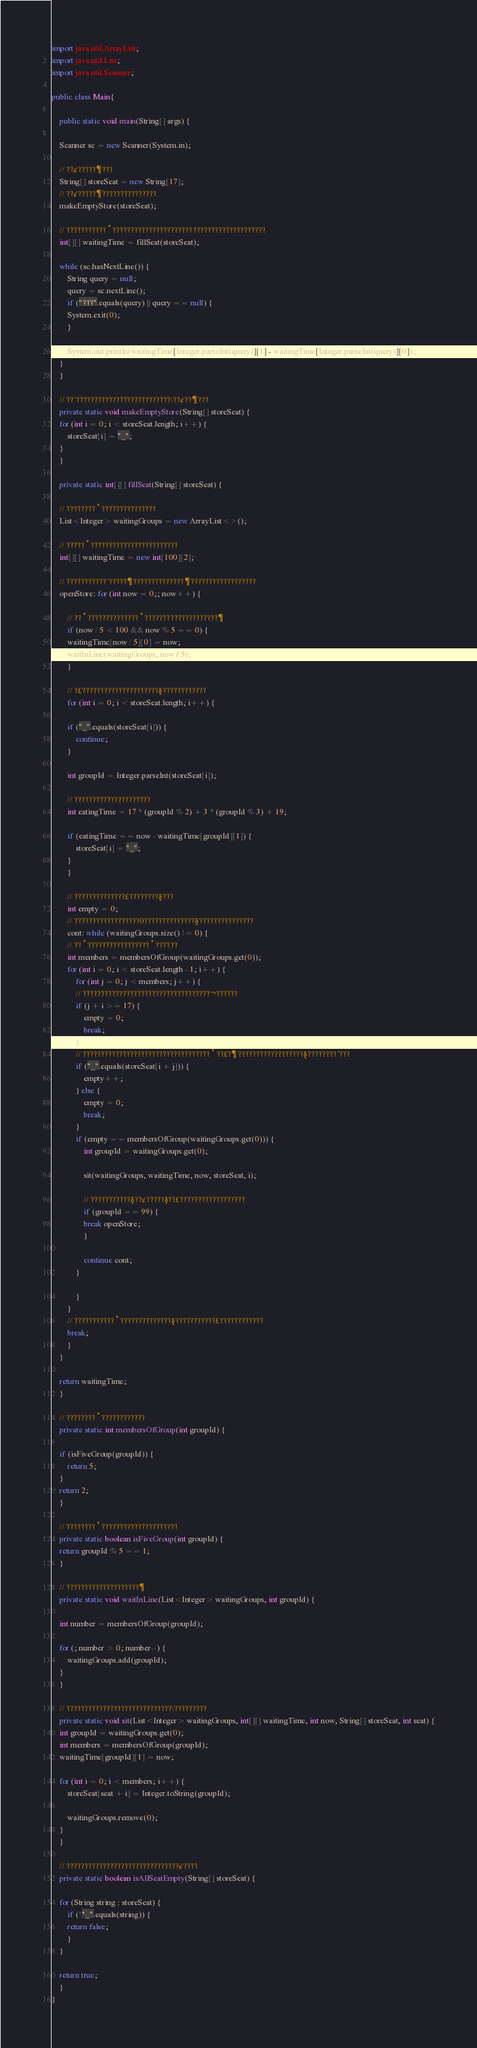Convert code to text. <code><loc_0><loc_0><loc_500><loc_500><_Java_>import java.util.ArrayList;
import java.util.List;
import java.util.Scanner;

public class Main{

    public static void main(String[] args) {

	Scanner sc = new Scanner(System.in);

	// ??¢?????¶???
	String[] storeSeat = new String[17];
	// ??¢?????¶???????????????
	makeEmptyStore(storeSeat);

	// ???????????°??????????????????????????????????????????
	int[][] waitingTime = fillSeat(storeSeat);

	while (sc.hasNextLine()) {
	    String query = null;
	    query = sc.nextLine();
	    if ("???".equals(query) || query == null) {
		System.exit(0);
	    }

	    System.out.println(waitingTime[Integer.parseInt(query)][1] - waitingTime[Integer.parseInt(query)][0]);
	}
    }

    // ??¨??????????????????????????\??¢??¶???
    private static void makeEmptyStore(String[] storeSeat) {
	for (int i = 0; i < storeSeat.length; i++) {
	    storeSeat[i] = "_";
	}
    }

    private static int[][] fillSeat(String[] storeSeat) {

	// ????????°???????????????
	List<Integer> waitingGroups = new ArrayList<>();

	// ?????°????????????????????????
	int[][] waitingTime = new int[100][2];

	// ???????????¨?????¶??????????????¶??????????????????
	openStore: for (int now = 0;; now++) {

	    // ??°??????????????°????????????????????¶
	    if (now / 5 < 100 && now % 5 == 0) {
		waitingTime[now / 5][0] = now;
		waitInLine(waitingGroups, now / 5);
	    }

	    // ?£?????????????????????§????????????
	    for (int i = 0; i < storeSeat.length; i++) {

		if ("_".equals(storeSeat[i])) {
		    continue;
		}

		int groupId = Integer.parseInt(storeSeat[i]);

		// ?????????????????????
		int eatingTime = 17 * (groupId % 2) + 3 * (groupId % 3) + 19;

		if (eatingTime == now - waitingTime[groupId][1]) {
		    storeSeat[i] = "_";
		}
	    }

	    // ??????????????£????????§???
	    int empty = 0;
	    // ??????????????????0??????????????§???????????????
	    cont: while (waitingGroups.size() != 0) {
		// ??°?????????????????°??????
		int members = membersOfGroup(waitingGroups.get(0));
		for (int i = 0; i < storeSeat.length - 1; i++) {
		    for (int j = 0; j < members; j++) {
			// ???????????????????????????????????¬??????
			if (j + i >= 17) {
			    empty = 0;
			    break;
			}
			// ???????????????????????????????????°??£?¶??????????????????§????????´???
			if ("_".equals(storeSeat[i + j])) {
			    empty++;
			} else {
			    empty = 0;
			    break;
			}
			if (empty == membersOfGroup(waitingGroups.get(0))) {
			    int groupId = waitingGroups.get(0);

			    sit(waitingGroups, waitingTime, now, storeSeat, i);

			    // ???????????§??¢?????§??£??????????????????
			    if (groupId == 99) {
				break openStore;
			    }

			    continue cont;
			}

		    }
		}
		// ???????????°??????????????§???????????£????????????
		break;
	    }
	}

	return waitingTime;
    }

    // ????????°????????????
    private static int membersOfGroup(int groupId) {

	if (isFiveGroup(groupId)) {
	    return 5;
	}
	return 2;
    }

    // ????????°?????????????????????
    private static boolean isFiveGroup(int groupId) {
	return groupId % 5 == 1;
    }

    // ????????????????????¶
    private static void waitInLine(List<Integer> waitingGroups, int groupId) {

	int number = membersOfGroup(groupId);

	for (; number > 0; number--) {
	    waitingGroups.add(groupId);
	}
    }

    // ?????????????????????????????\?????????
    private static void sit(List<Integer> waitingGroups, int[][] waitingTime, int now, String[] storeSeat, int seat) {
	int groupId = waitingGroups.get(0);
	int members = membersOfGroup(groupId);
	waitingTime[groupId][1] = now;

	for (int i = 0; i < members; i++) {
	    storeSeat[seat + i] = Integer.toString(groupId);

	    waitingGroups.remove(0);
	}
    }

    // ???????????????????????????????¢????
    private static boolean isAllSeatEmpty(String[] storeSeat) {

	for (String string : storeSeat) {
	    if (!"_".equals(string)) {
		return false;
	    }
	}

	return true;
    }
}</code> 